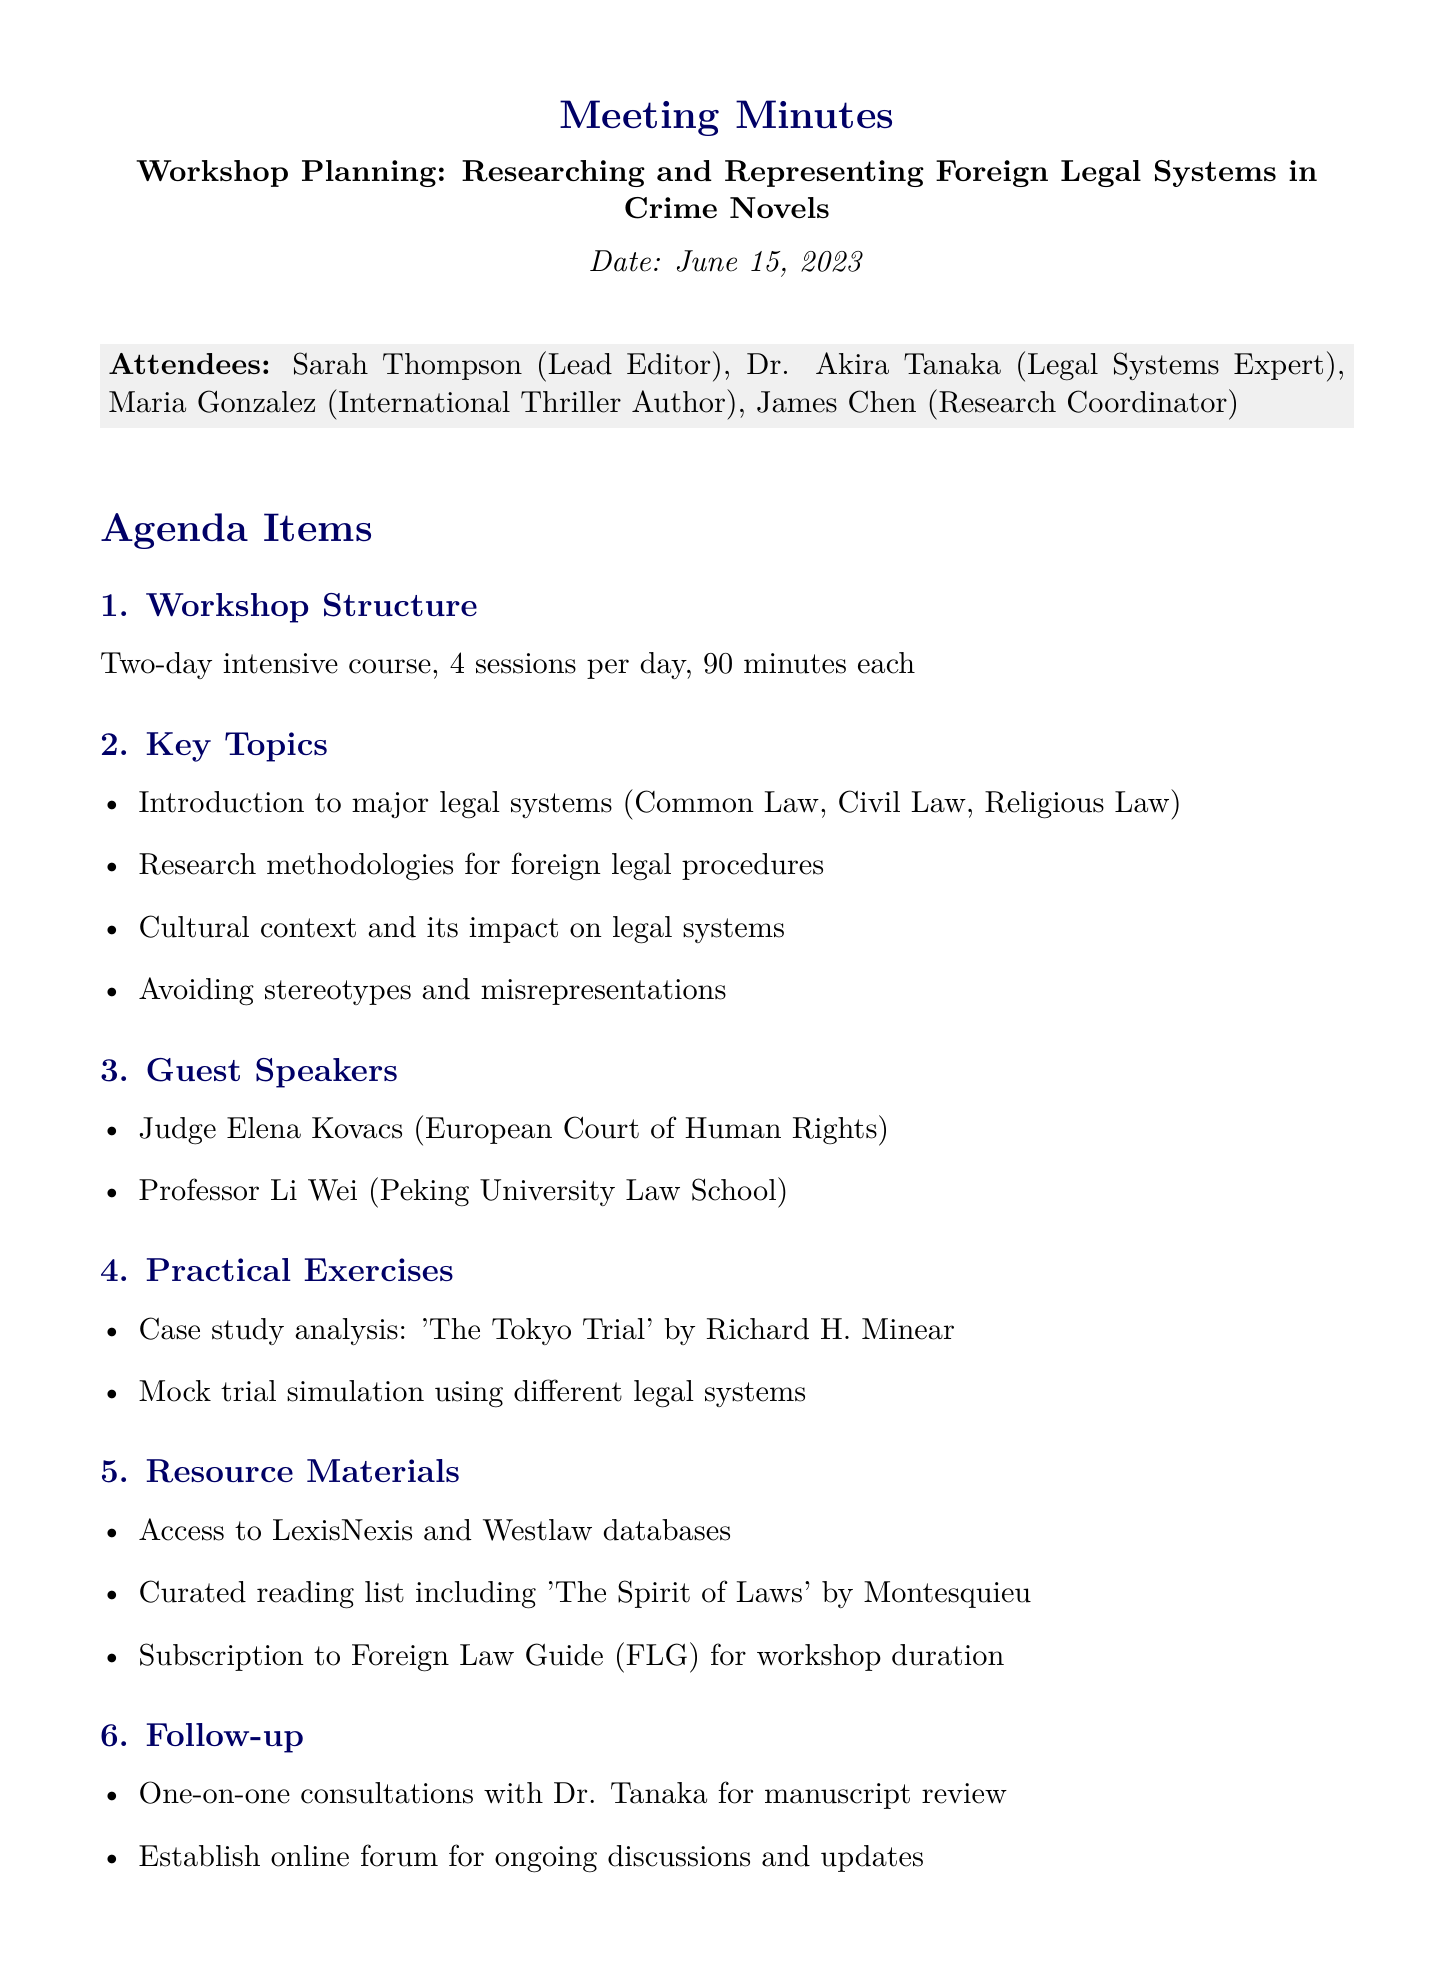What is the date of the workshop planning meeting? The date of the workshop planning meeting is explicitly mentioned in the document.
Answer: June 15, 2023 Who is the Lead Editor mentioned in the attendees? The attendees section lists specific individuals, including their roles.
Answer: Sarah Thompson How many sessions are planned for each day of the workshop? The workshop structure specifies the number of sessions per day.
Answer: 4 sessions What are the key topics covered in the workshop? The key topics are listed in the agenda item, specifying areas of focus.
Answer: Introduction to major legal systems, Research methodologies for foreign legal procedures, Cultural context and its impact on legal systems, Avoiding stereotypes and misrepresentations Who is one of the guest speakers at the workshop? The guest speakers are outlined in the agenda item specifying their names and affiliations.
Answer: Judge Elena Kovacs What practical exercise involves a case study analysis? The practical exercises section details activities planned for the workshop.
Answer: 'The Tokyo Trial' by Richard H. Minear What are one of the resources participants will have access to during the workshop? The resource materials section lists various resources participants will access.
Answer: LexisNexis and Westlaw databases What is one of the follow-up actions mentioned in the meeting minutes? The follow-up section includes specific actions decided upon during the meeting.
Answer: One-on-one consultations with Dr. Tanaka for manuscript review What is the total number of days for the workshop? The duration of the workshop is specified in the structure of the workshop.
Answer: Two-day 